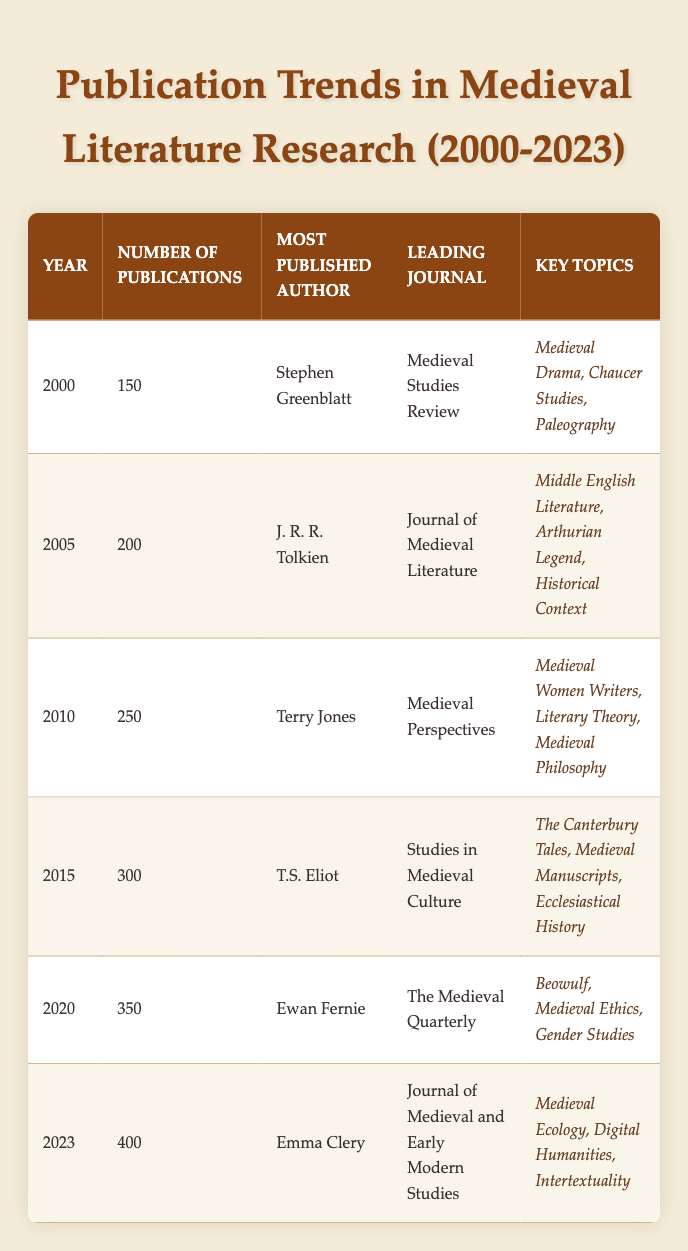What was the number of publications in 2010? The table lists 2010 as having 250 publications, which can be found in the "Number of Publications" column for that year.
Answer: 250 Who was the most published author in 2015? The year 2015 shows that T.S. Eliot was the most published author, as indicated in the corresponding column for that year.
Answer: T.S. Eliot Which journal was leading in 2023? In the year 2023, the leading journal was the "Journal of Medieval and Early Modern Studies," as noted in the table under that year.
Answer: Journal of Medieval and Early Modern Studies Are there more publications in 2020 than in 2015? Comparing the numbers, 2020 has 350 publications and 2015 has 300 publications. Since 350 is greater than 300, this statement is true.
Answer: Yes What is the average number of publications from 2000 to 2023? To find the average, sum the publications for each year: 150 + 200 + 250 + 300 + 350 + 400 = 1650. There are 6 years, so the average is 1650 / 6 = 275.
Answer: 275 Which key topic appeared consistently in 2010 and 2015? Examining the key topics for those years, "Ecclesiastical History" appears in 2015, while 2010's key topics do not list it. However, there is no overlap. Both years present distinct key topics, so no topics are found in both.
Answer: None How many more publications were there in 2023 compared to 2000? The difference in publications is calculated by subtracting the number of publications in 2000 (150) from those in 2023 (400): 400 - 150 = 250, resulting in an increase of 250 publications.
Answer: 250 Was "Medieval Drama" one of the key topics in 2023? Checking the key topics for 2023, they are "Medieval Ecology," "Digital Humanities," and "Intertextuality." Since "Medieval Drama" is not listed, the statement is false.
Answer: No What was the trend in the number of publications from 2000 to 2023? Observing the number of publications over the years: 150 in 2000, 200 in 2005, 250 in 2010, 300 in 2015, 350 in 2020, and 400 in 2023 shows a steady upward trend each year with increasing publications.
Answer: Steady increase 